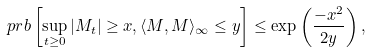<formula> <loc_0><loc_0><loc_500><loc_500>\ p r b \left [ \sup _ { t \geq 0 } | M _ { t } | \geq x , \langle M , M \rangle _ { \infty } \leq y \right ] \leq \exp \left ( \frac { - x ^ { 2 } } { 2 y } \right ) ,</formula> 